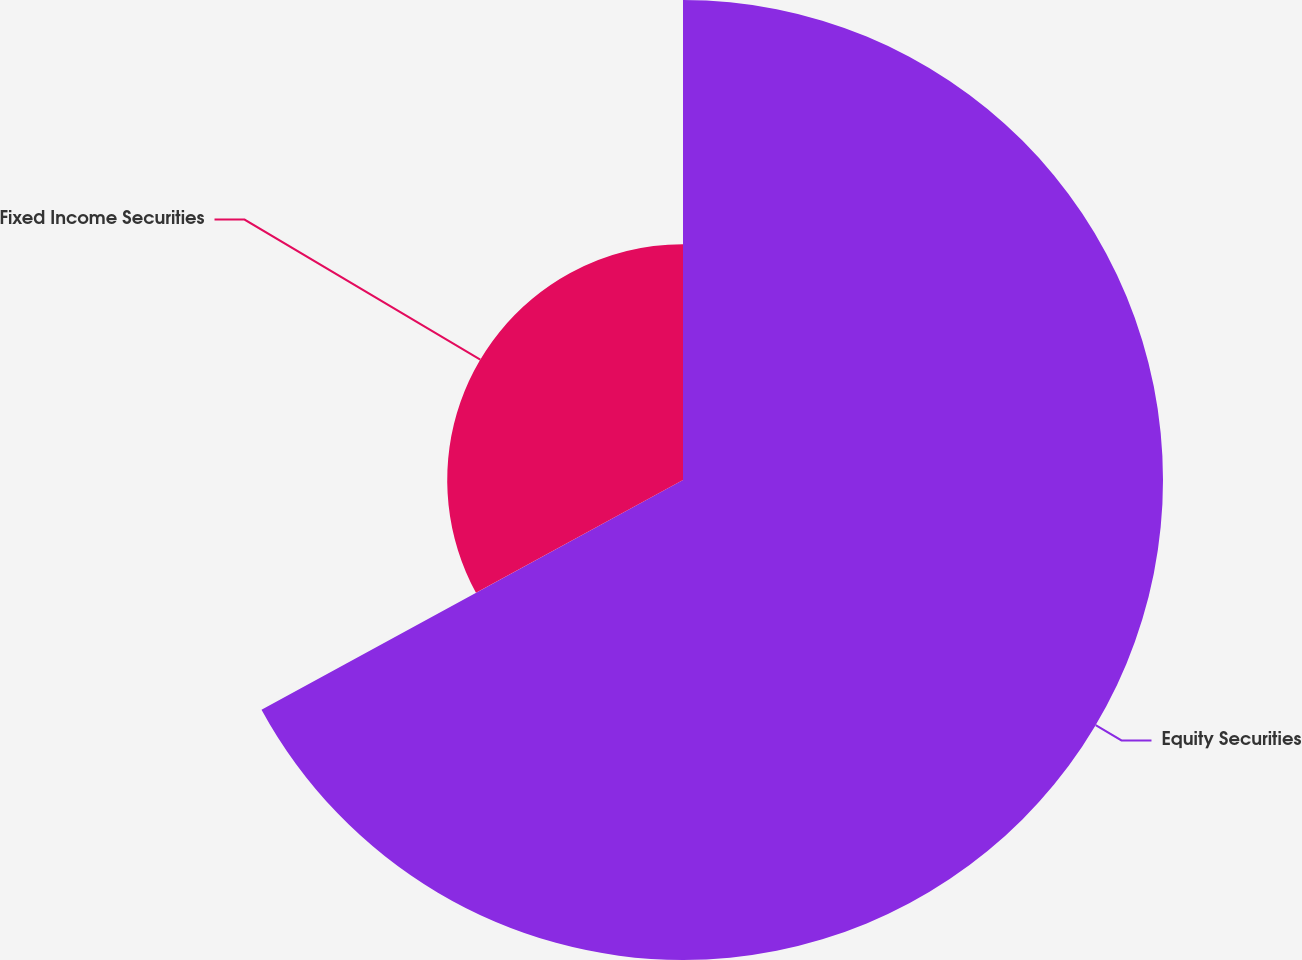Convert chart. <chart><loc_0><loc_0><loc_500><loc_500><pie_chart><fcel>Equity Securities<fcel>Fixed Income Securities<nl><fcel>67.06%<fcel>32.94%<nl></chart> 